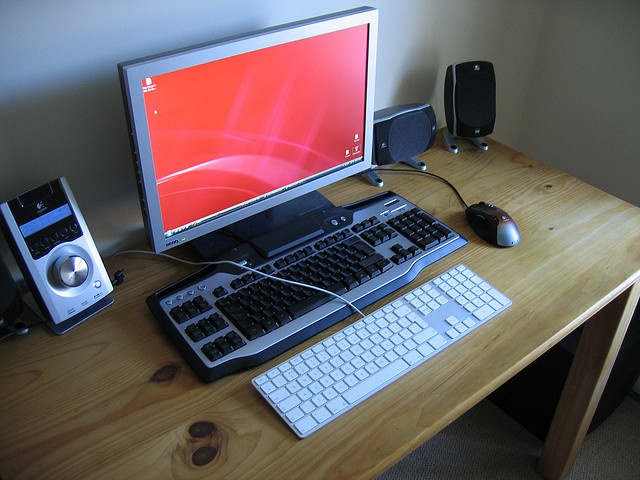Describe the objects in this image and their specific colors. I can see tv in gray, salmon, and lavender tones, keyboard in gray, black, and navy tones, keyboard in gray, lightblue, and darkgray tones, and mouse in gray, black, and blue tones in this image. 